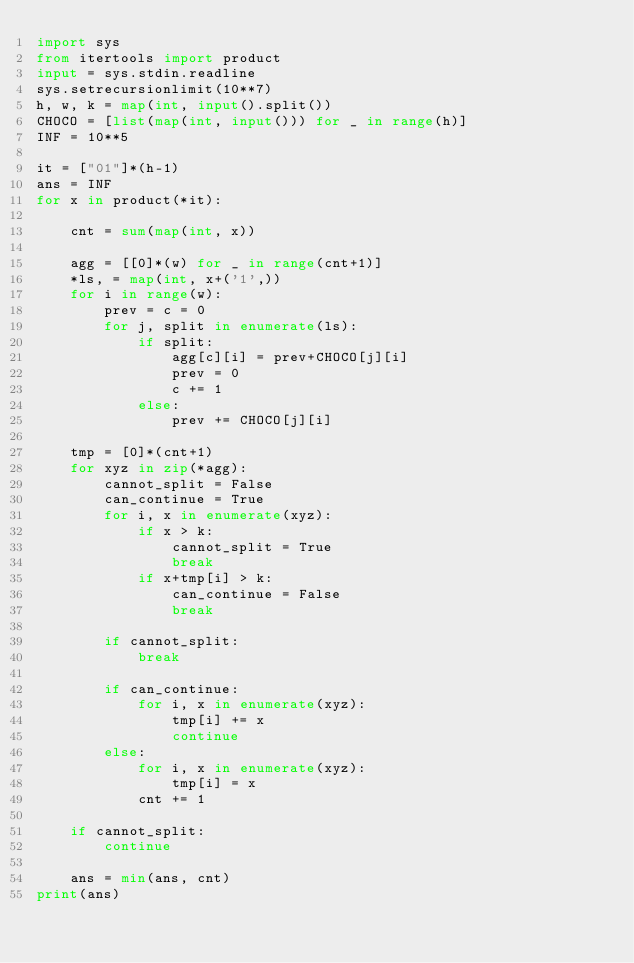<code> <loc_0><loc_0><loc_500><loc_500><_Python_>import sys
from itertools import product
input = sys.stdin.readline
sys.setrecursionlimit(10**7)
h, w, k = map(int, input().split())
CHOCO = [list(map(int, input())) for _ in range(h)]
INF = 10**5

it = ["01"]*(h-1)
ans = INF
for x in product(*it):

    cnt = sum(map(int, x))

    agg = [[0]*(w) for _ in range(cnt+1)]
    *ls, = map(int, x+('1',))
    for i in range(w):
        prev = c = 0
        for j, split in enumerate(ls):
            if split:
                agg[c][i] = prev+CHOCO[j][i]
                prev = 0
                c += 1
            else:
                prev += CHOCO[j][i]

    tmp = [0]*(cnt+1)
    for xyz in zip(*agg):
        cannot_split = False
        can_continue = True
        for i, x in enumerate(xyz):
            if x > k:
                cannot_split = True
                break
            if x+tmp[i] > k:
                can_continue = False
                break

        if cannot_split:
            break

        if can_continue:
            for i, x in enumerate(xyz):
                tmp[i] += x
                continue
        else:
            for i, x in enumerate(xyz):
                tmp[i] = x
            cnt += 1

    if cannot_split:
        continue

    ans = min(ans, cnt)
print(ans)
</code> 